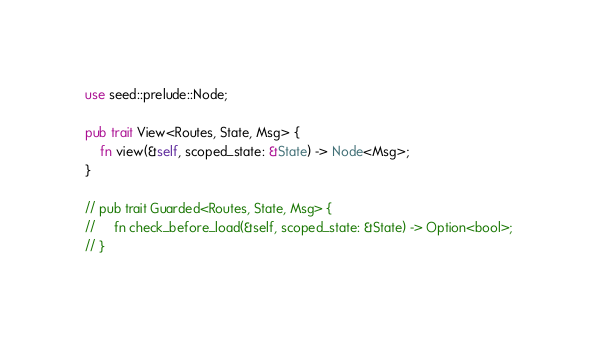Convert code to text. <code><loc_0><loc_0><loc_500><loc_500><_Rust_>use seed::prelude::Node;

pub trait View<Routes, State, Msg> {
    fn view(&self, scoped_state: &State) -> Node<Msg>;
}

// pub trait Guarded<Routes, State, Msg> {
//     fn check_before_load(&self, scoped_state: &State) -> Option<bool>;
// }
</code> 